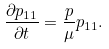<formula> <loc_0><loc_0><loc_500><loc_500>\frac { \partial p _ { 1 1 } } { \partial t } = \frac { p } { \mu } p _ { 1 1 } .</formula> 